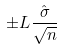<formula> <loc_0><loc_0><loc_500><loc_500>\pm L \frac { \hat { \sigma } } { \sqrt { n } }</formula> 